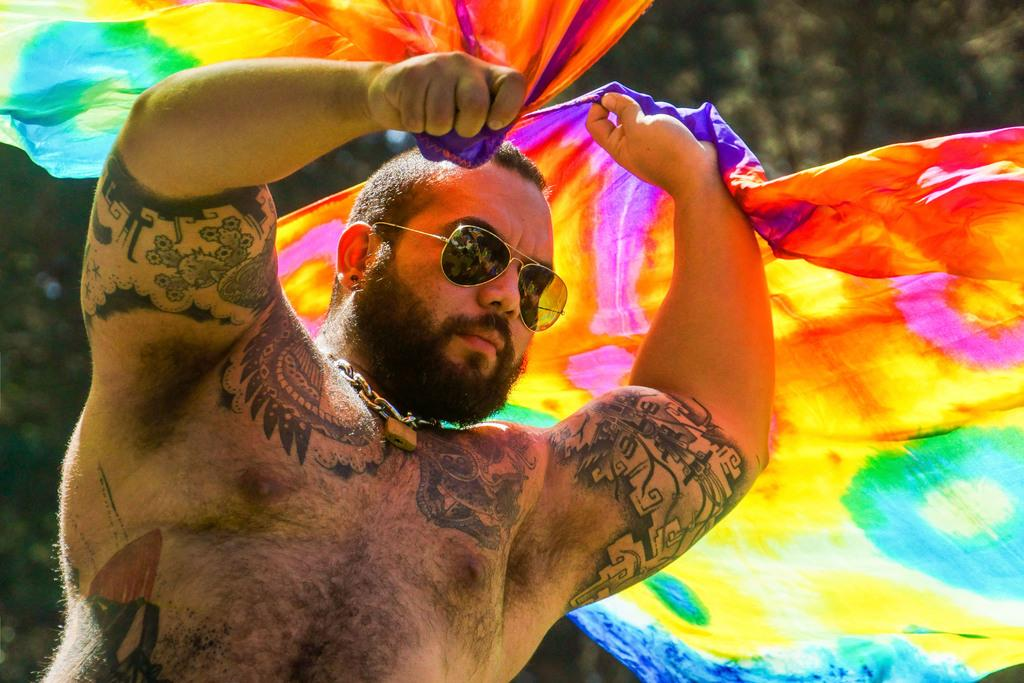What is the main subject of the image? The main subject of the image is a man. What is the man doing in the image? The man is standing and holding clothes. What type of natural environment is visible in the image? There are trees visible in the image. Can you tell me where the cord is tied to in the image? There is no cord present in the image. What type of water body can be seen in the image? There is no water body, such as a lake, present in the image. 